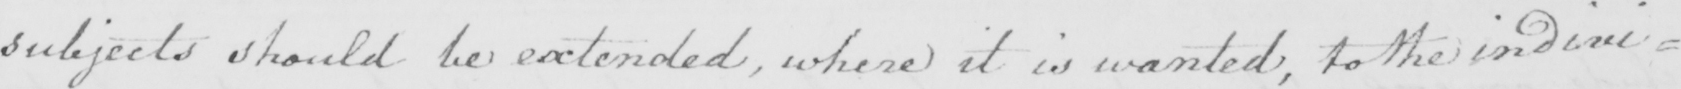What does this handwritten line say? subjects should be extended , where it is wanted , to the indivi= 